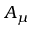Convert formula to latex. <formula><loc_0><loc_0><loc_500><loc_500>A _ { \mu }</formula> 